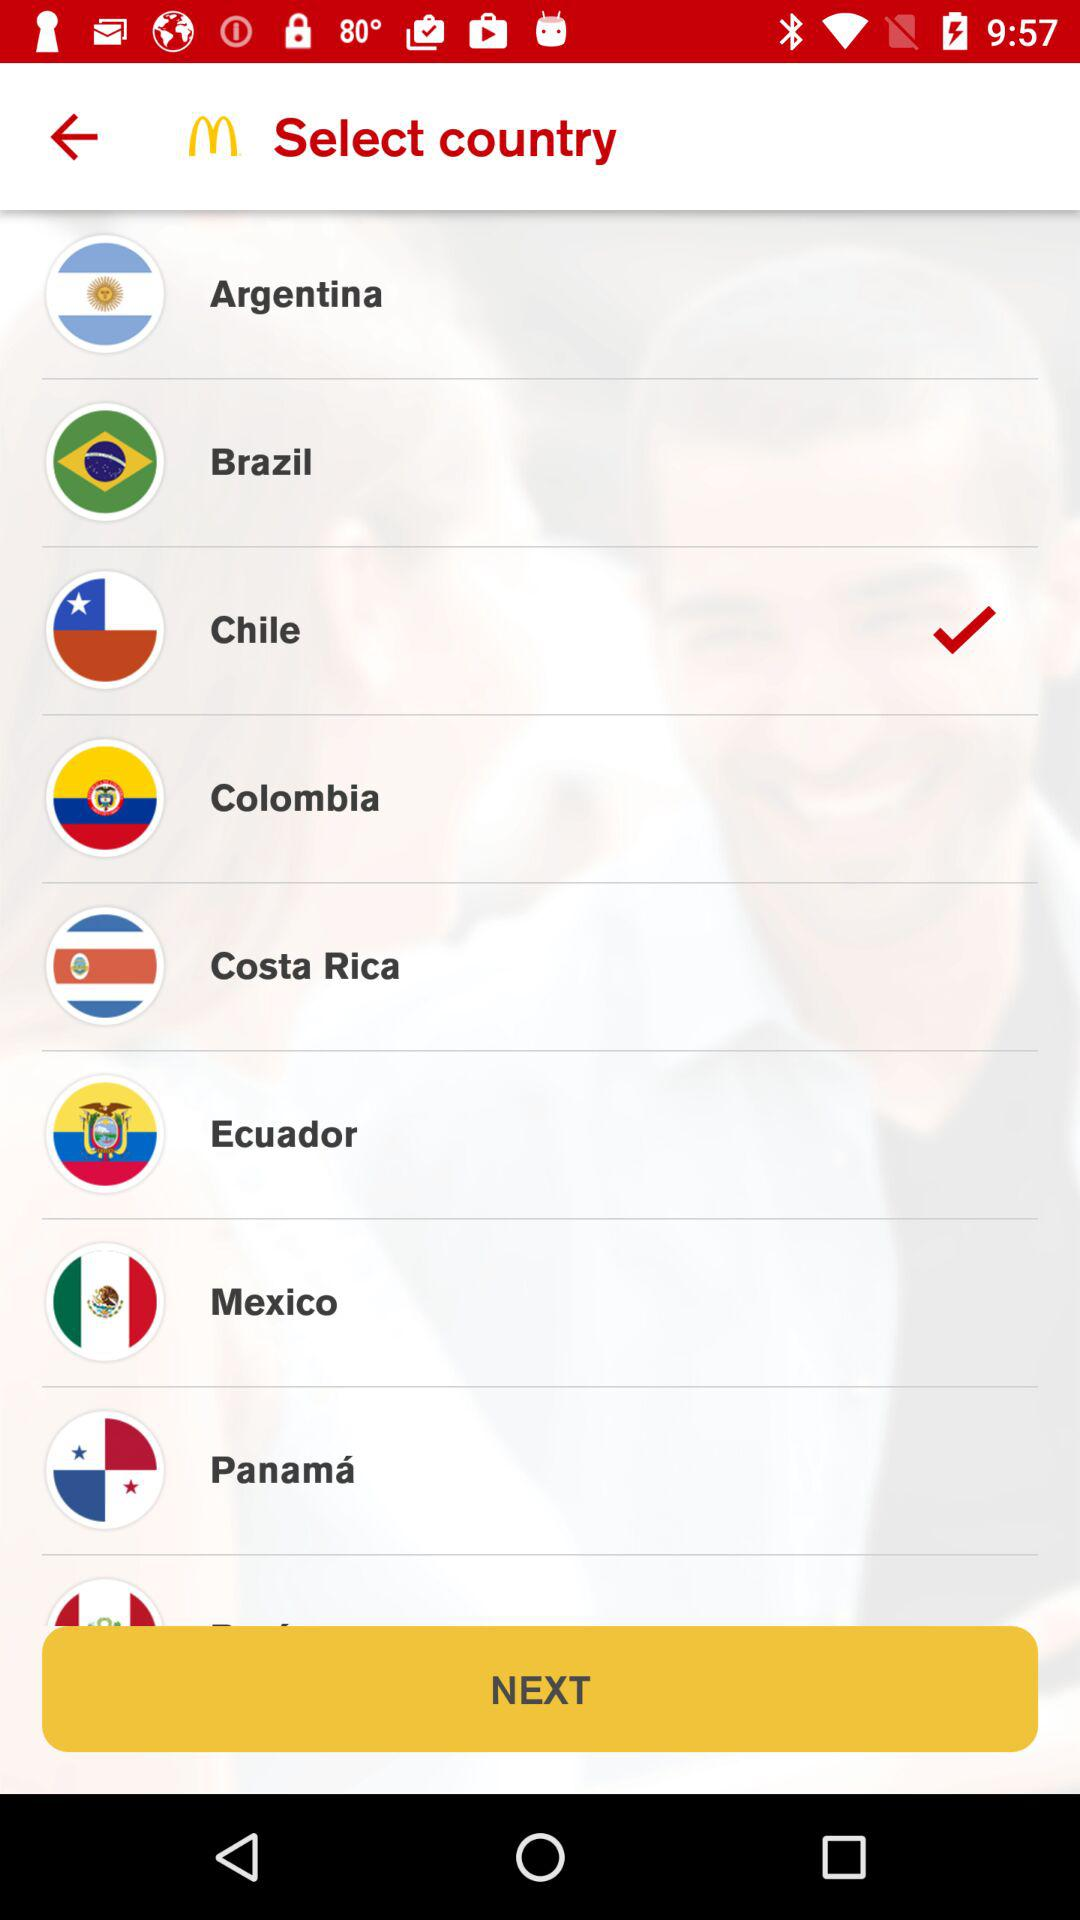Which is the selected country? The selected country is Chile. 